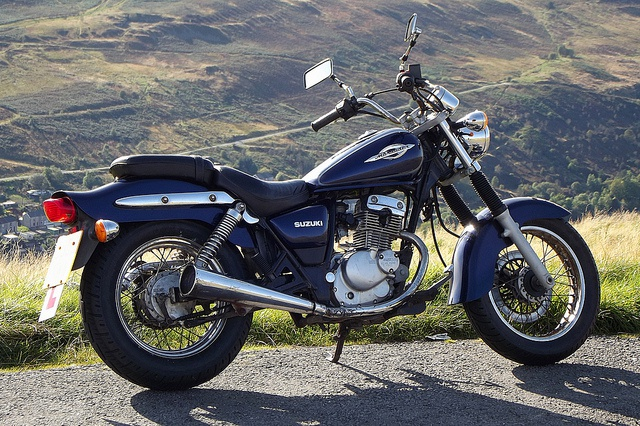Describe the objects in this image and their specific colors. I can see a motorcycle in gray, black, navy, and white tones in this image. 